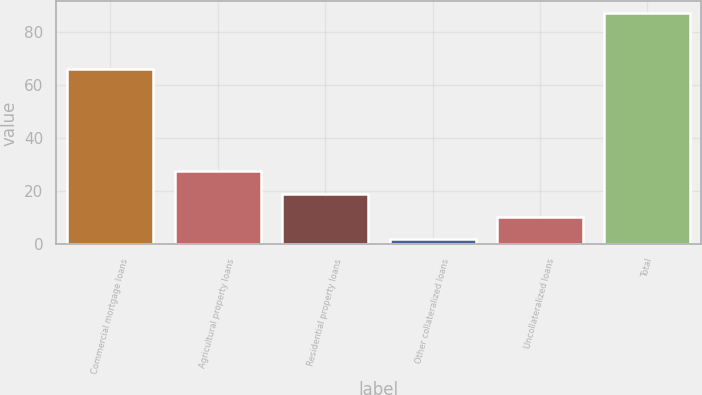Convert chart. <chart><loc_0><loc_0><loc_500><loc_500><bar_chart><fcel>Commercial mortgage loans<fcel>Agricultural property loans<fcel>Residential property loans<fcel>Other collateralized loans<fcel>Uncollateralized loans<fcel>Total<nl><fcel>66<fcel>27.47<fcel>18.96<fcel>1.94<fcel>10.45<fcel>87<nl></chart> 